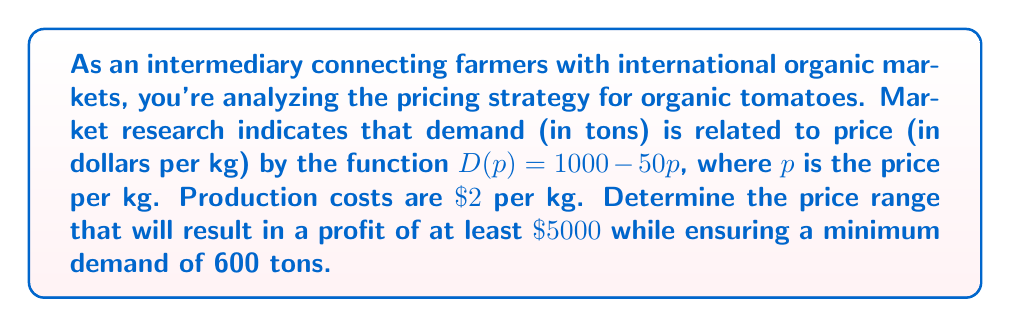Show me your answer to this math problem. Let's approach this step-by-step:

1) First, we need to set up the profit function. Profit is revenue minus cost:
   $$ \text{Profit} = \text{Revenue} - \text{Cost} $$
   $$ \pi(p) = pD(p) - 2D(p) $$

2) Substitute the demand function:
   $$ \pi(p) = p(1000 - 50p) - 2(1000 - 50p) $$
   $$ \pi(p) = 1000p - 50p^2 - 2000 + 100p $$
   $$ \pi(p) = -50p^2 + 1100p - 2000 $$

3) We want profit to be at least $\$5000$:
   $$ -50p^2 + 1100p - 2000 \geq 5000 $$
   $$ -50p^2 + 1100p - 7000 \geq 0 $$

4) Solve this quadratic inequality:
   $$ -50(p^2 - 22p + 140) \geq 0 $$
   $$ p^2 - 22p + 140 \leq 0 $$
   $$ (p - 20)(p - 2) \leq 0 $$
   This is true for $2 \leq p \leq 20$

5) Now, we need to ensure a minimum demand of 600 tons:
   $$ 1000 - 50p \geq 600 $$
   $$ -50p \geq -400 $$
   $$ p \leq 8 $$

6) Combining the conditions from steps 4 and 5:
   $$ 2 \leq p \leq 8 $$

Therefore, the price range that satisfies both conditions is $\$2$ to $\$8$ per kg.
Answer: The optimal price range for organic tomatoes is $\$2$ to $\$8$ per kg. 